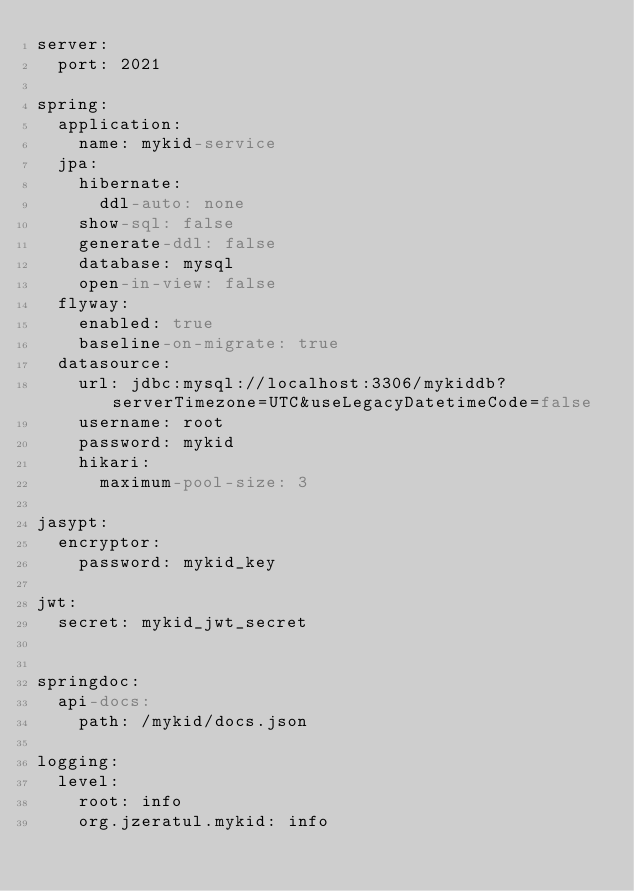Convert code to text. <code><loc_0><loc_0><loc_500><loc_500><_YAML_>server:
  port: 2021

spring:
  application:
    name: mykid-service
  jpa:
    hibernate:
      ddl-auto: none
    show-sql: false
    generate-ddl: false
    database: mysql
    open-in-view: false
  flyway:
    enabled: true
    baseline-on-migrate: true
  datasource:
    url: jdbc:mysql://localhost:3306/mykiddb?serverTimezone=UTC&useLegacyDatetimeCode=false
    username: root
    password: mykid
    hikari:
      maximum-pool-size: 3

jasypt:
  encryptor:
    password: mykid_key

jwt:
  secret: mykid_jwt_secret


springdoc:
  api-docs:
    path: /mykid/docs.json

logging:
  level:
    root: info
    org.jzeratul.mykid: info
</code> 